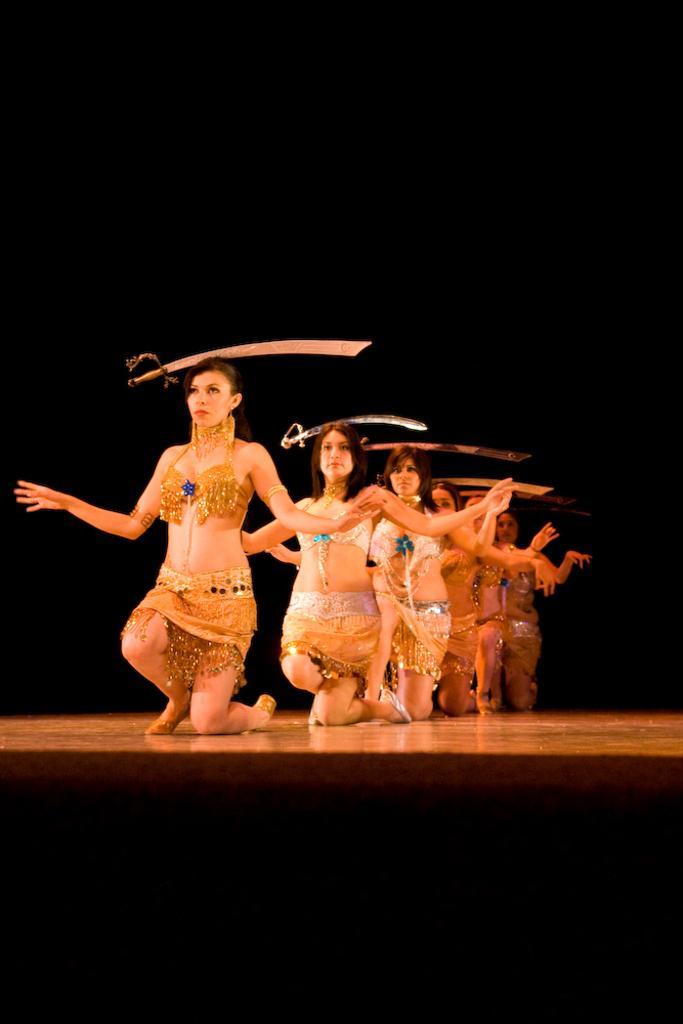Could you give a brief overview of what you see in this image? In this image there are a few people sitting on their knees on the stage and on their heads there are swords. The background is dark. 